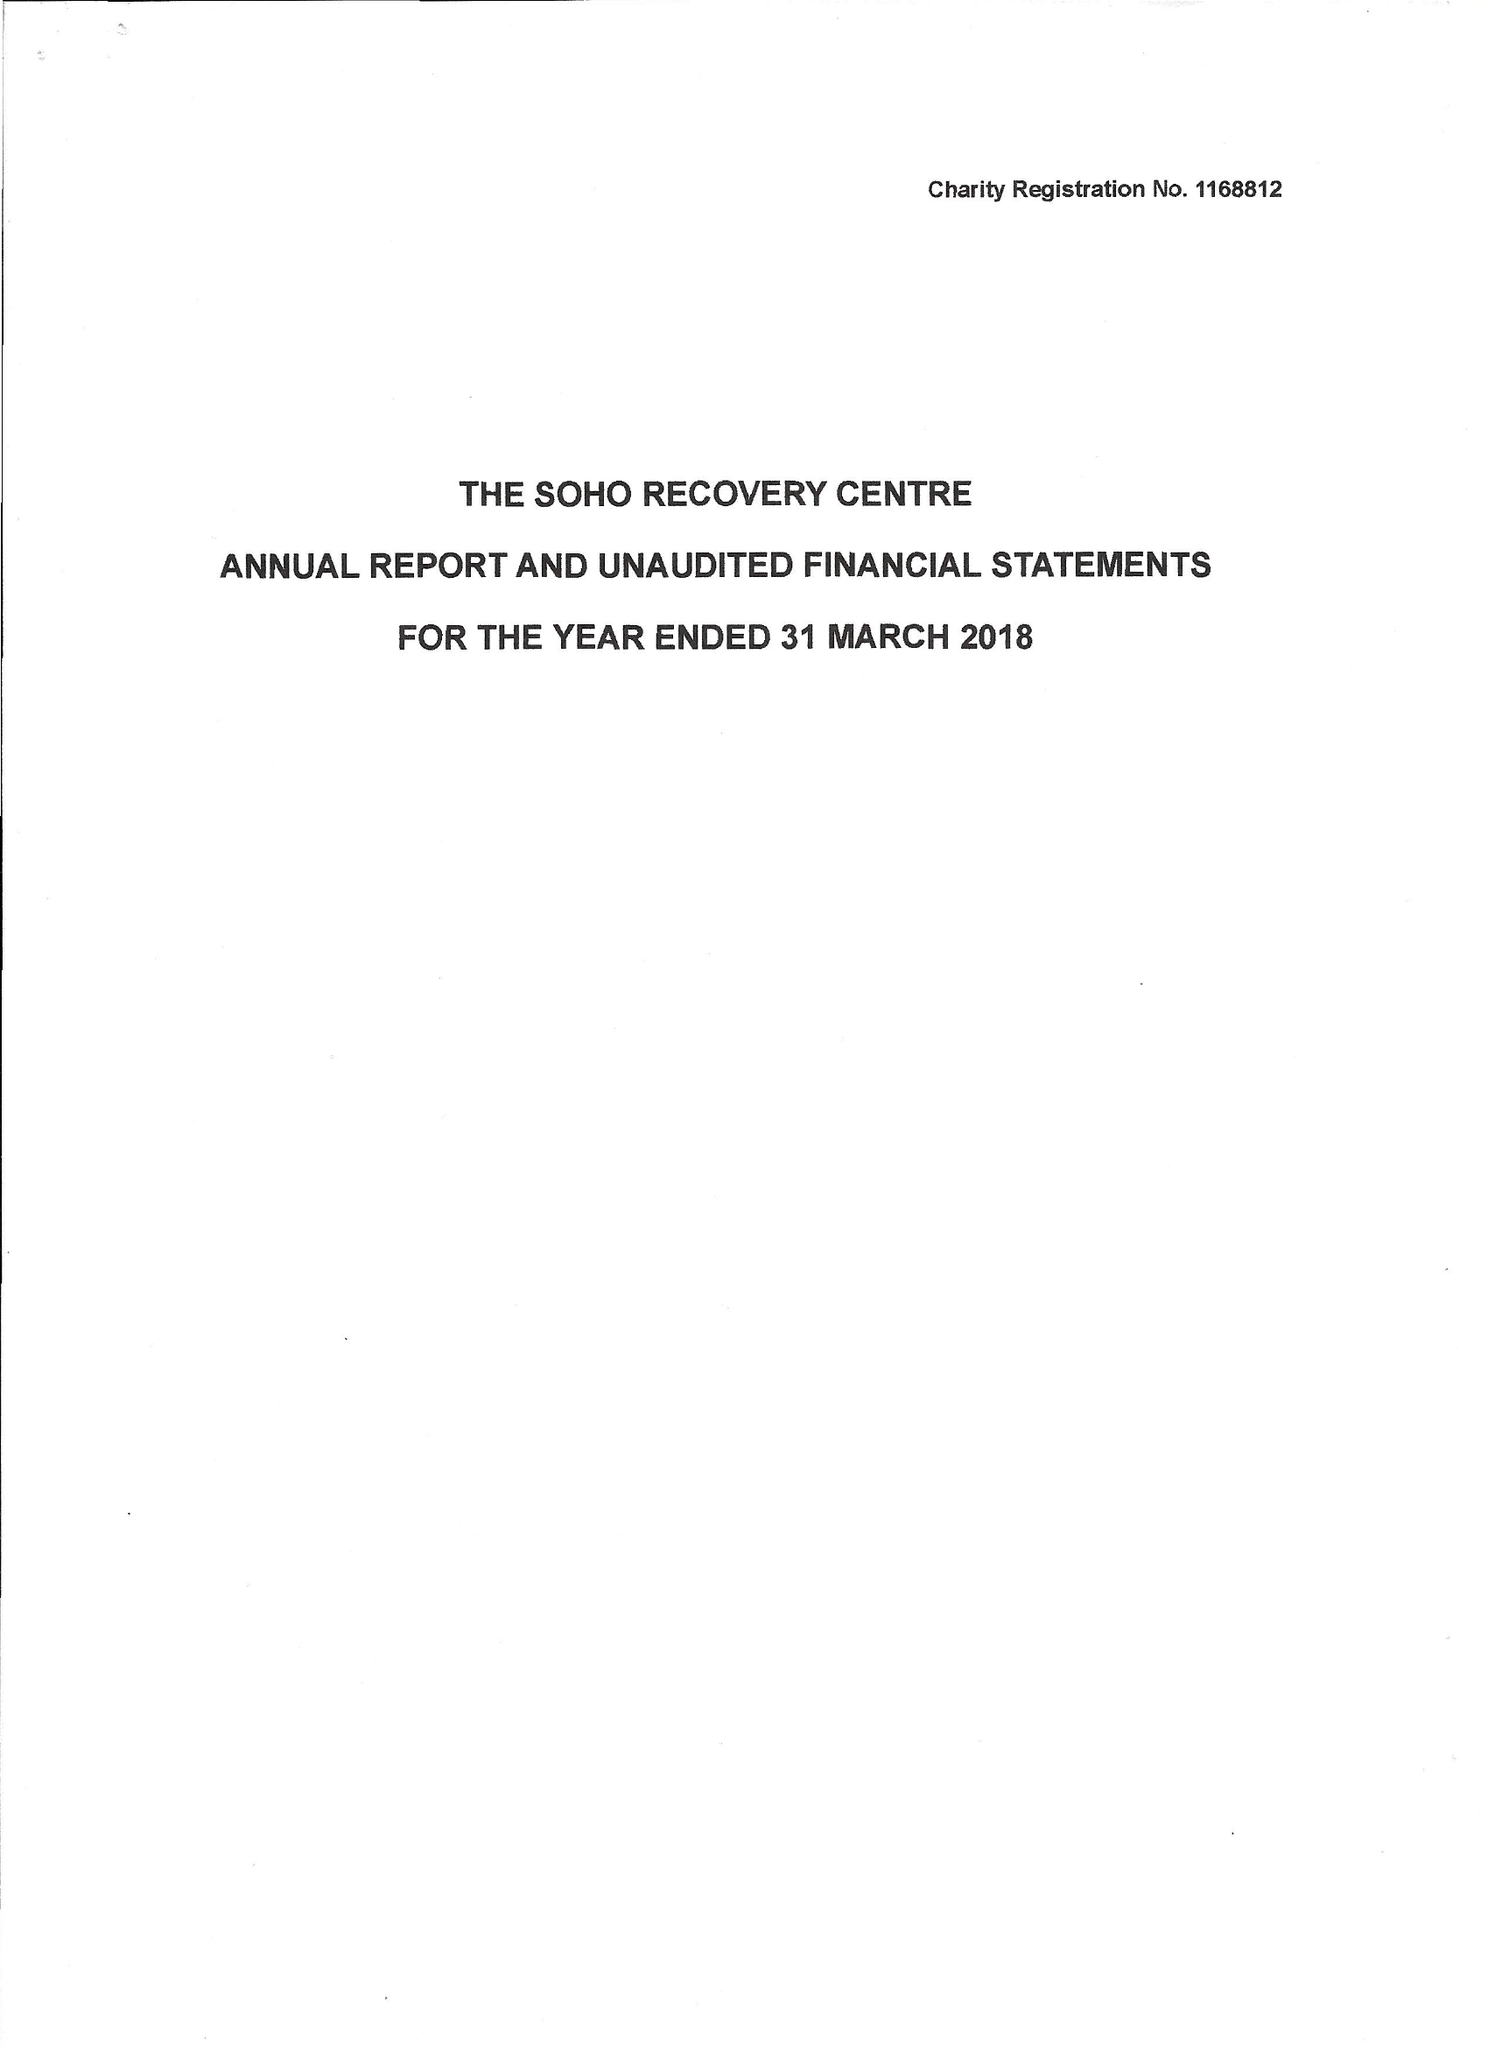What is the value for the report_date?
Answer the question using a single word or phrase. 2018-03-31 